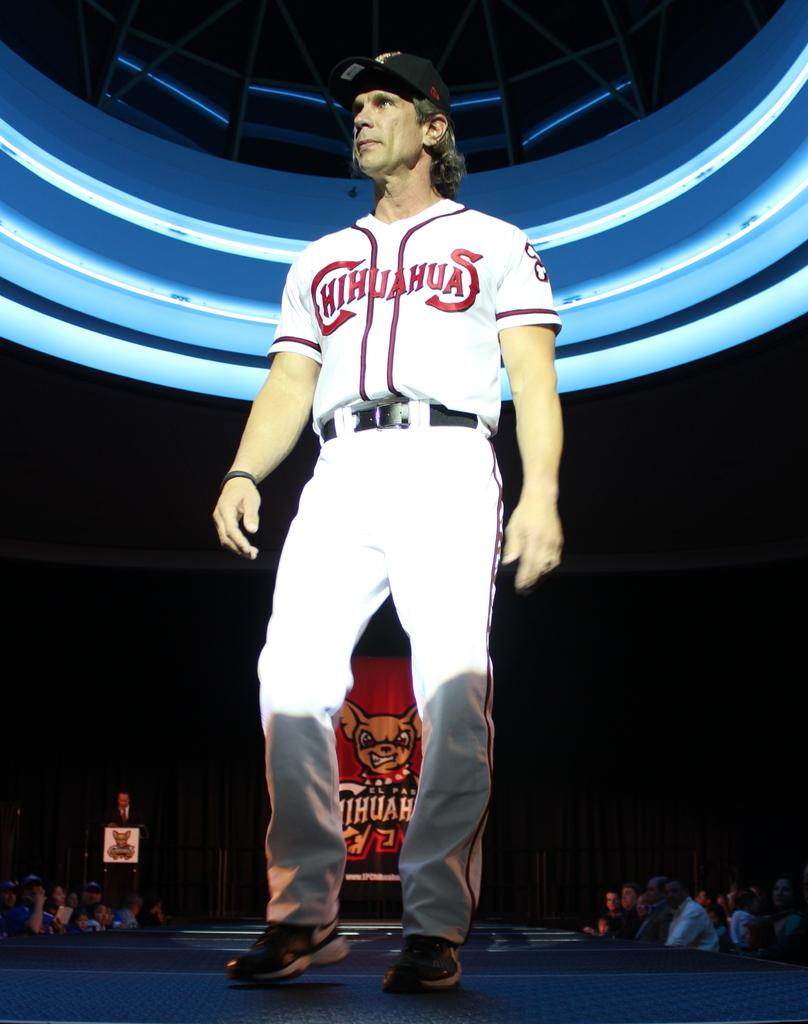Provide a one-sentence caption for the provided image. One of the El Paso Chihuahuas players on stage. 